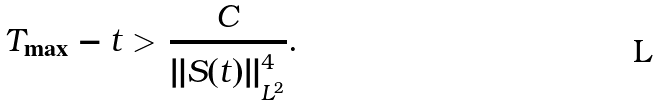<formula> <loc_0><loc_0><loc_500><loc_500>T _ { \max } - t > \frac { C } { \| S ( t ) \| _ { L ^ { 2 } } ^ { 4 } } .</formula> 